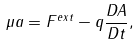Convert formula to latex. <formula><loc_0><loc_0><loc_500><loc_500>\mu a = F ^ { e x t } - q \frac { D A } { D t } ,</formula> 